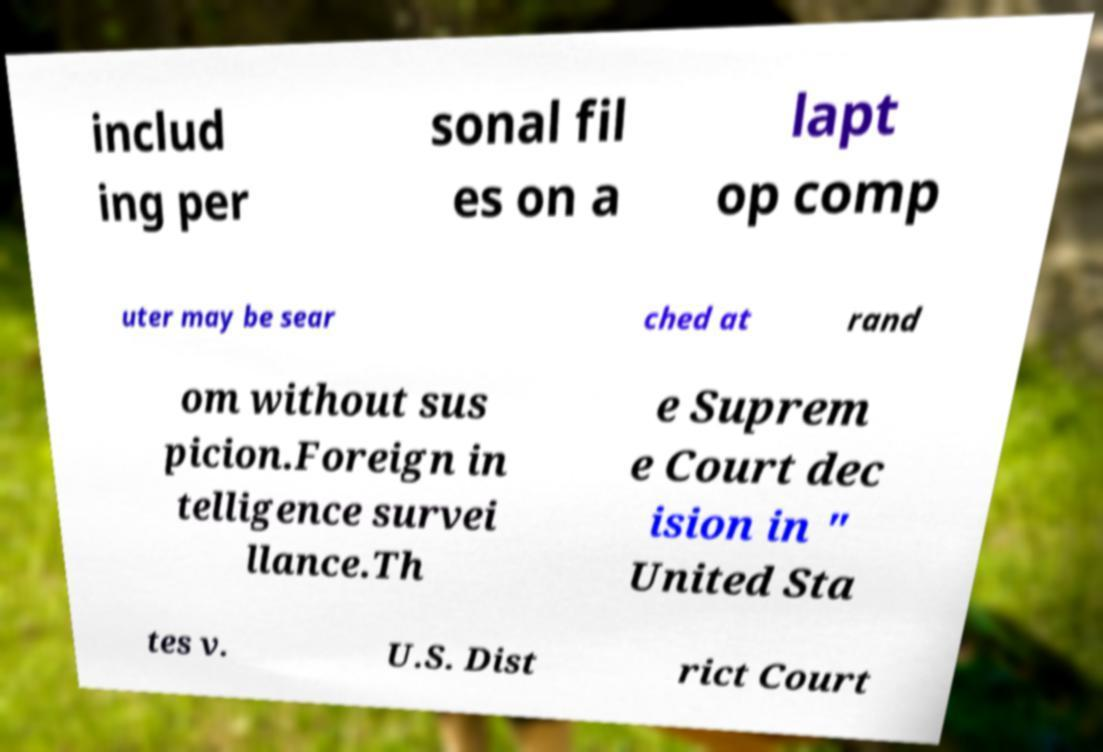Please identify and transcribe the text found in this image. includ ing per sonal fil es on a lapt op comp uter may be sear ched at rand om without sus picion.Foreign in telligence survei llance.Th e Suprem e Court dec ision in " United Sta tes v. U.S. Dist rict Court 